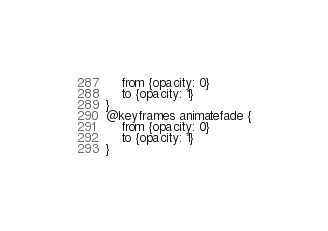Convert code to text. <code><loc_0><loc_0><loc_500><loc_500><_CSS_>	from {opacity: 0}
	to {opacity: 1}
}
@keyframes animatefade {
	from {opacity: 0}
	to {opacity: 1}
}</code> 